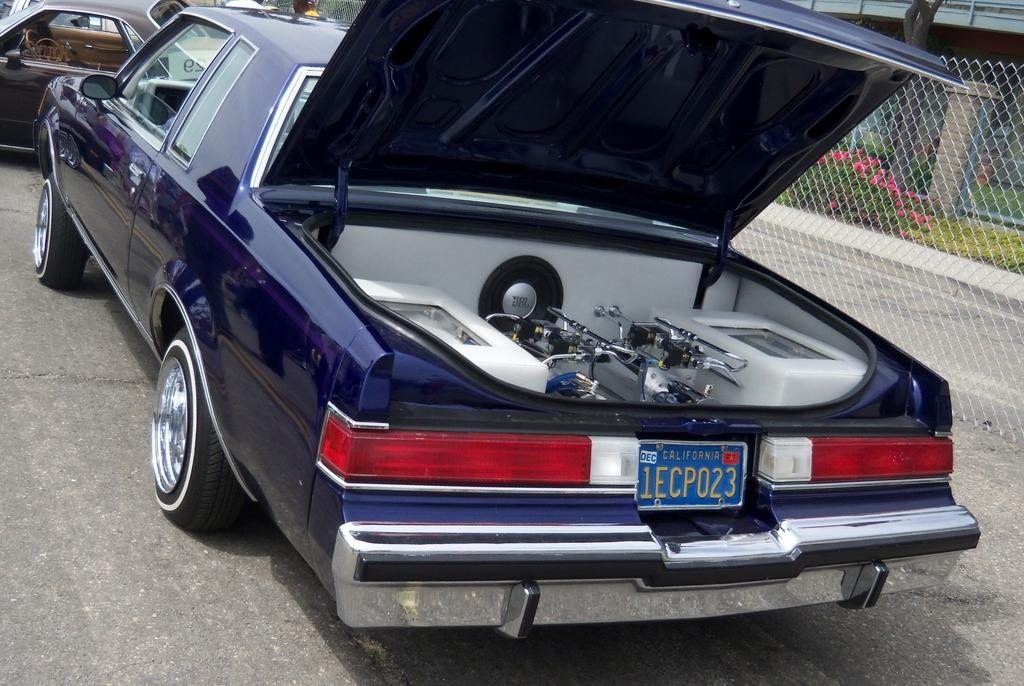<image>
Give a short and clear explanation of the subsequent image. a license plate that has 1ec on it 